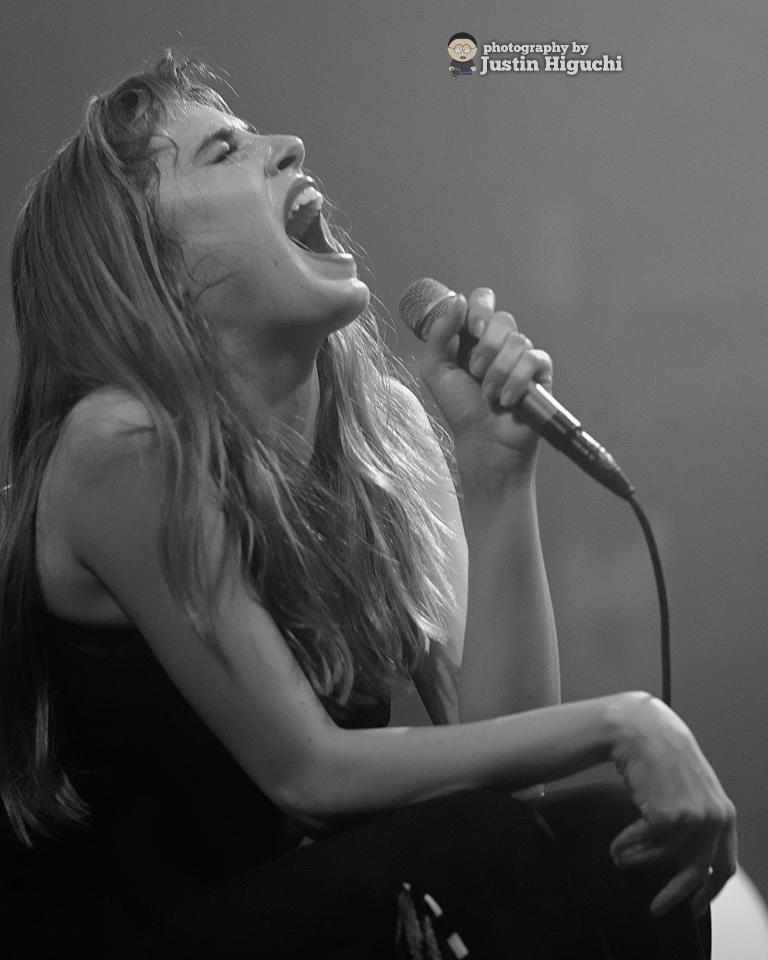What is the main subject of the image? There is a person in the image. What is the person doing in the image? The person is shouting. What object is the person holding in her hand? The person is holding a microphone in her hand. What is the person wearing in the image? The person is wearing a black dress. What type of crime is being committed in the wilderness in the image? There is no wilderness or crime present in the image; it features a person shouting while holding a microphone and wearing a black dress. 